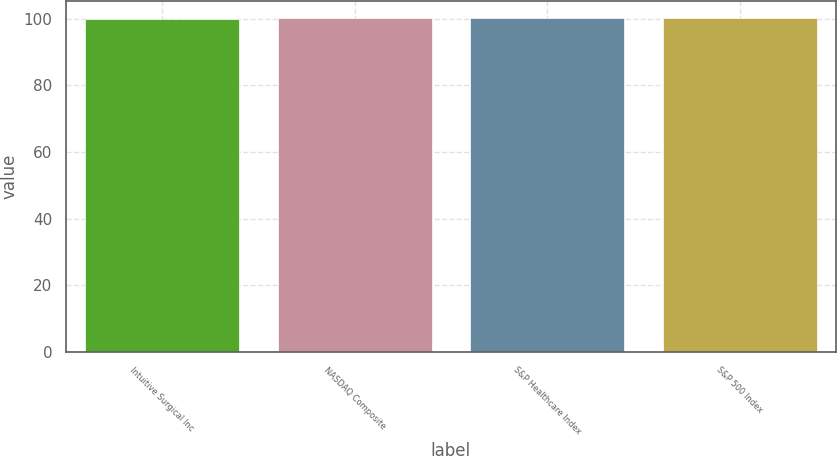<chart> <loc_0><loc_0><loc_500><loc_500><bar_chart><fcel>Intuitive Surgical Inc<fcel>NASDAQ Composite<fcel>S&P Healthcare Index<fcel>S&P 500 Index<nl><fcel>100<fcel>100.1<fcel>100.2<fcel>100.3<nl></chart> 